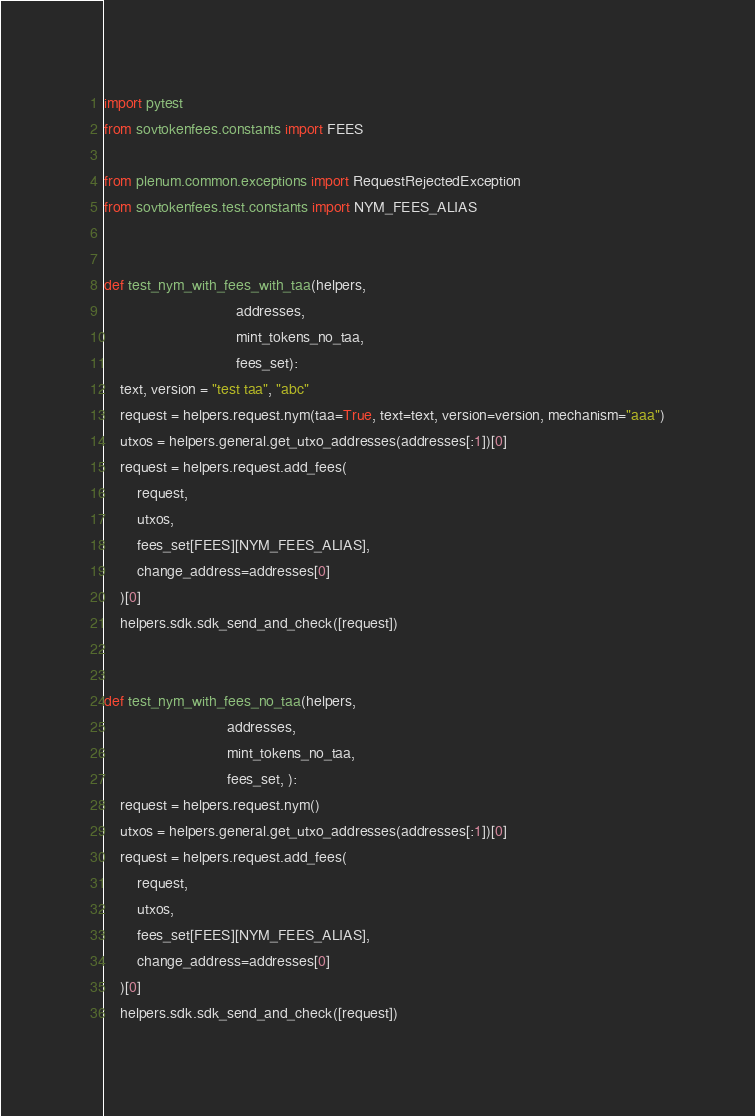<code> <loc_0><loc_0><loc_500><loc_500><_Python_>import pytest
from sovtokenfees.constants import FEES

from plenum.common.exceptions import RequestRejectedException
from sovtokenfees.test.constants import NYM_FEES_ALIAS


def test_nym_with_fees_with_taa(helpers,
                                addresses,
                                mint_tokens_no_taa,
                                fees_set):
    text, version = "test taa", "abc"
    request = helpers.request.nym(taa=True, text=text, version=version, mechanism="aaa")
    utxos = helpers.general.get_utxo_addresses(addresses[:1])[0]
    request = helpers.request.add_fees(
        request,
        utxos,
        fees_set[FEES][NYM_FEES_ALIAS],
        change_address=addresses[0]
    )[0]
    helpers.sdk.sdk_send_and_check([request])


def test_nym_with_fees_no_taa(helpers,
                              addresses,
                              mint_tokens_no_taa,
                              fees_set, ):
    request = helpers.request.nym()
    utxos = helpers.general.get_utxo_addresses(addresses[:1])[0]
    request = helpers.request.add_fees(
        request,
        utxos,
        fees_set[FEES][NYM_FEES_ALIAS],
        change_address=addresses[0]
    )[0]
    helpers.sdk.sdk_send_and_check([request])
</code> 